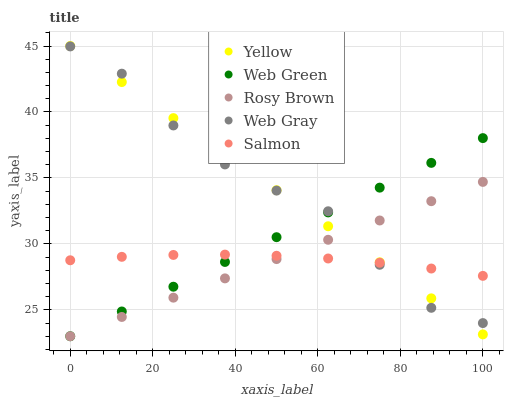Does Salmon have the minimum area under the curve?
Answer yes or no. Yes. Does Yellow have the maximum area under the curve?
Answer yes or no. Yes. Does Rosy Brown have the minimum area under the curve?
Answer yes or no. No. Does Rosy Brown have the maximum area under the curve?
Answer yes or no. No. Is Rosy Brown the smoothest?
Answer yes or no. Yes. Is Web Gray the roughest?
Answer yes or no. Yes. Is Web Gray the smoothest?
Answer yes or no. No. Is Rosy Brown the roughest?
Answer yes or no. No. Does Rosy Brown have the lowest value?
Answer yes or no. Yes. Does Web Gray have the lowest value?
Answer yes or no. No. Does Yellow have the highest value?
Answer yes or no. Yes. Does Rosy Brown have the highest value?
Answer yes or no. No. Does Yellow intersect Web Gray?
Answer yes or no. Yes. Is Yellow less than Web Gray?
Answer yes or no. No. Is Yellow greater than Web Gray?
Answer yes or no. No. 